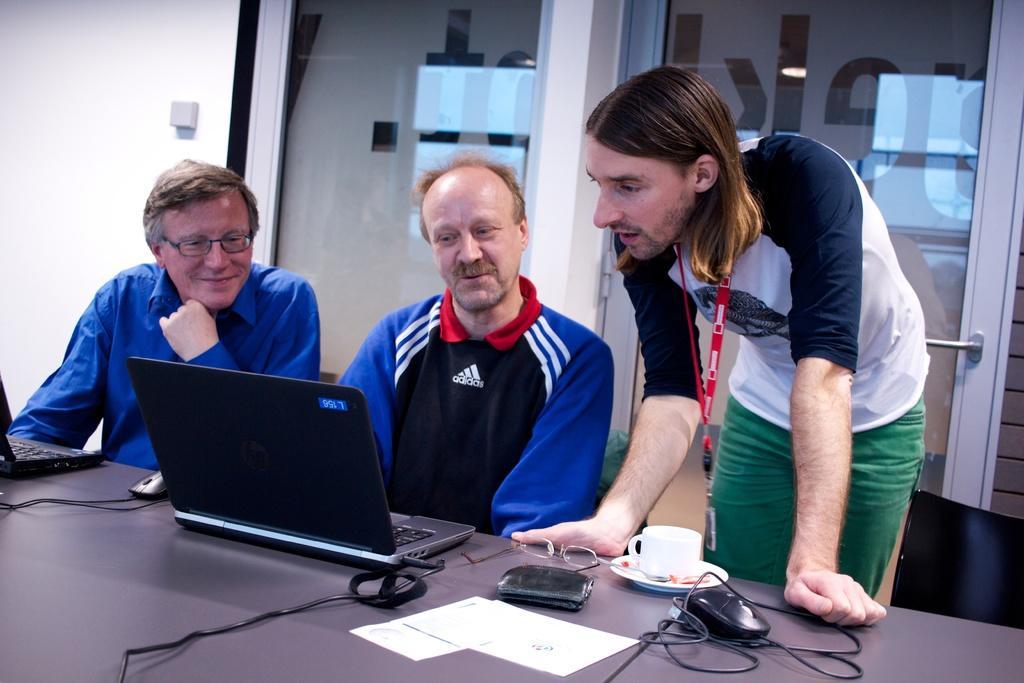Could you give a brief overview of what you see in this image? In this image, we can see people sitting and one of them is wearing glasses and on the right, there is an other person wearing an id card and in the background, there are doors and there is a wall. At the bottom, we can see laptops, mouses, glasses, papers and a wallet and a cup with saucer and some cables are on the table. 